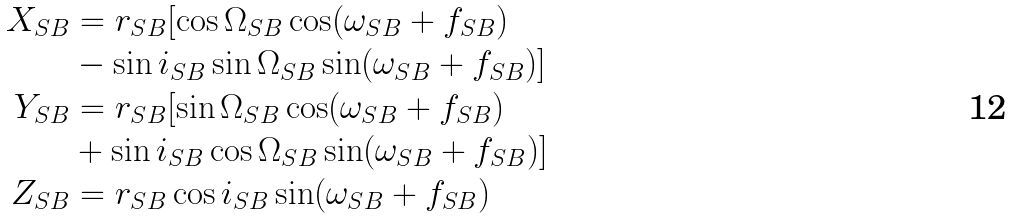<formula> <loc_0><loc_0><loc_500><loc_500>X _ { S B } & = r _ { S B } [ \cos \Omega _ { S B } \cos ( \omega _ { S B } + f _ { S B } ) \\ \quad & - \sin i _ { S B } \sin \Omega _ { S B } \sin ( \omega _ { S B } + f _ { S B } ) ] \\ Y _ { S B } & = r _ { S B } [ \sin \Omega _ { S B } \cos ( \omega _ { S B } + f _ { S B } ) \\ \quad & + \sin i _ { S B } \cos \Omega _ { S B } \sin ( \omega _ { S B } + f _ { S B } ) ] \\ Z _ { S B } & = r _ { S B } \cos i _ { S B } \sin ( \omega _ { S B } + f _ { S B } )</formula> 